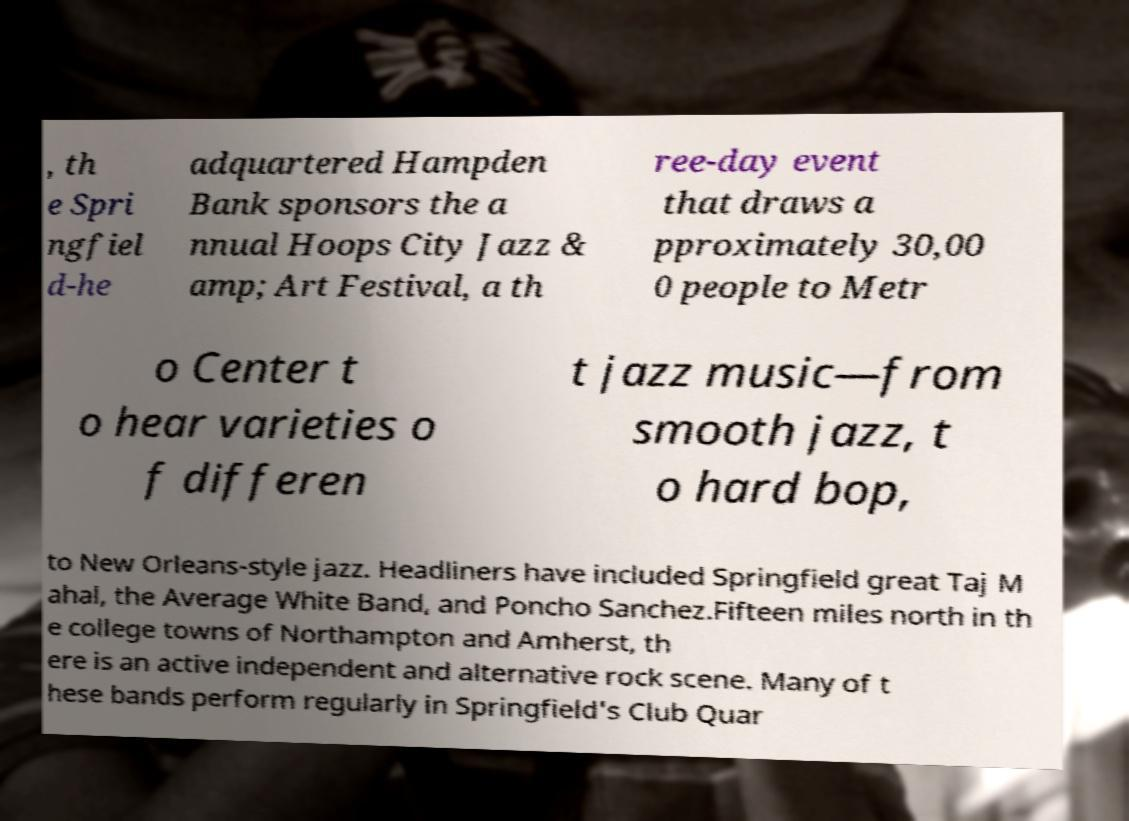There's text embedded in this image that I need extracted. Can you transcribe it verbatim? , th e Spri ngfiel d-he adquartered Hampden Bank sponsors the a nnual Hoops City Jazz & amp; Art Festival, a th ree-day event that draws a pproximately 30,00 0 people to Metr o Center t o hear varieties o f differen t jazz music—from smooth jazz, t o hard bop, to New Orleans-style jazz. Headliners have included Springfield great Taj M ahal, the Average White Band, and Poncho Sanchez.Fifteen miles north in th e college towns of Northampton and Amherst, th ere is an active independent and alternative rock scene. Many of t hese bands perform regularly in Springfield's Club Quar 